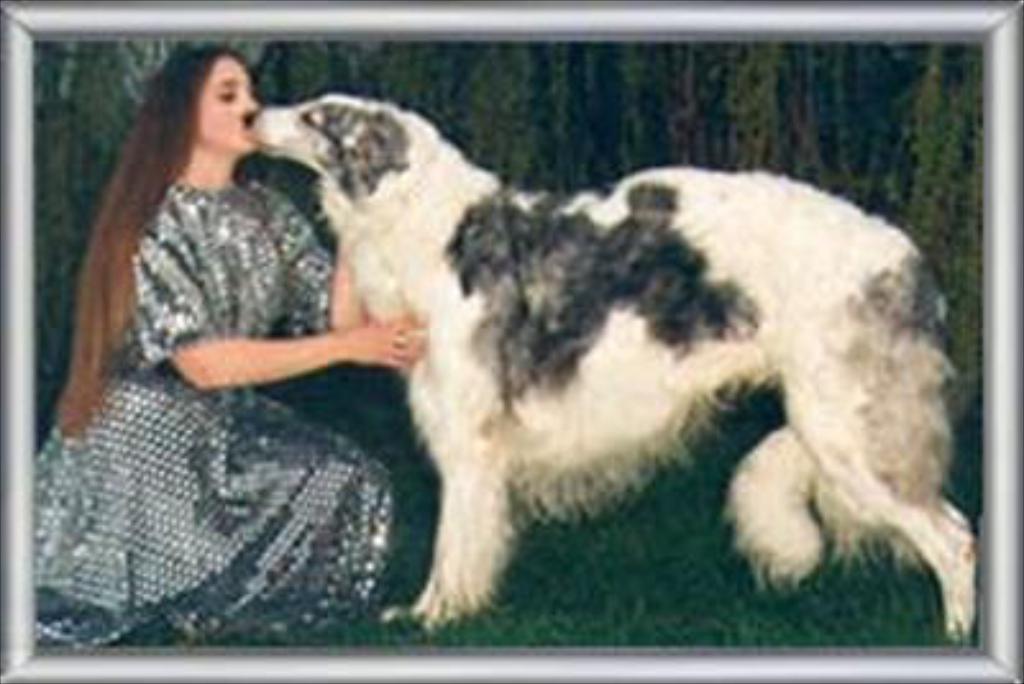Can you describe this image briefly? In this image there is a painting. In the painting it looks like there is a girl who is kissing the dog which is in front of her. 